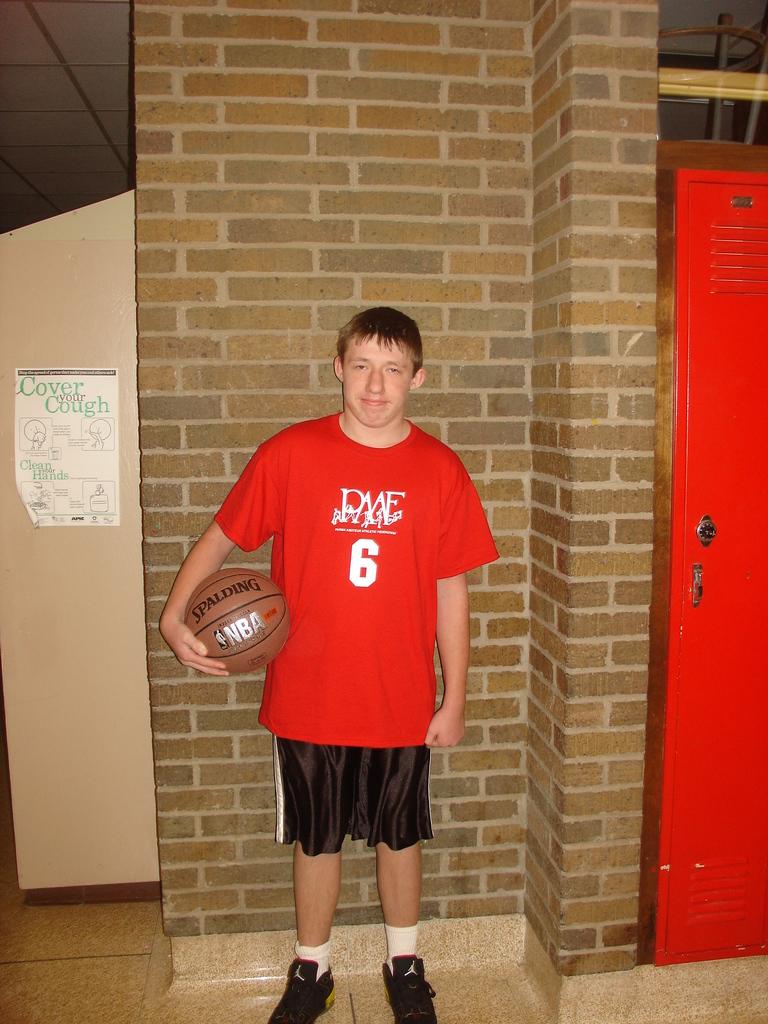What does the sign to the left of the person say to cover?
Your answer should be compact. Cover your cough. 